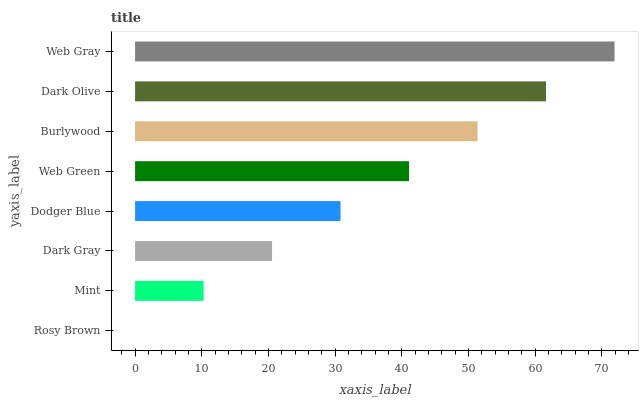Is Rosy Brown the minimum?
Answer yes or no. Yes. Is Web Gray the maximum?
Answer yes or no. Yes. Is Mint the minimum?
Answer yes or no. No. Is Mint the maximum?
Answer yes or no. No. Is Mint greater than Rosy Brown?
Answer yes or no. Yes. Is Rosy Brown less than Mint?
Answer yes or no. Yes. Is Rosy Brown greater than Mint?
Answer yes or no. No. Is Mint less than Rosy Brown?
Answer yes or no. No. Is Web Green the high median?
Answer yes or no. Yes. Is Dodger Blue the low median?
Answer yes or no. Yes. Is Dark Gray the high median?
Answer yes or no. No. Is Web Green the low median?
Answer yes or no. No. 